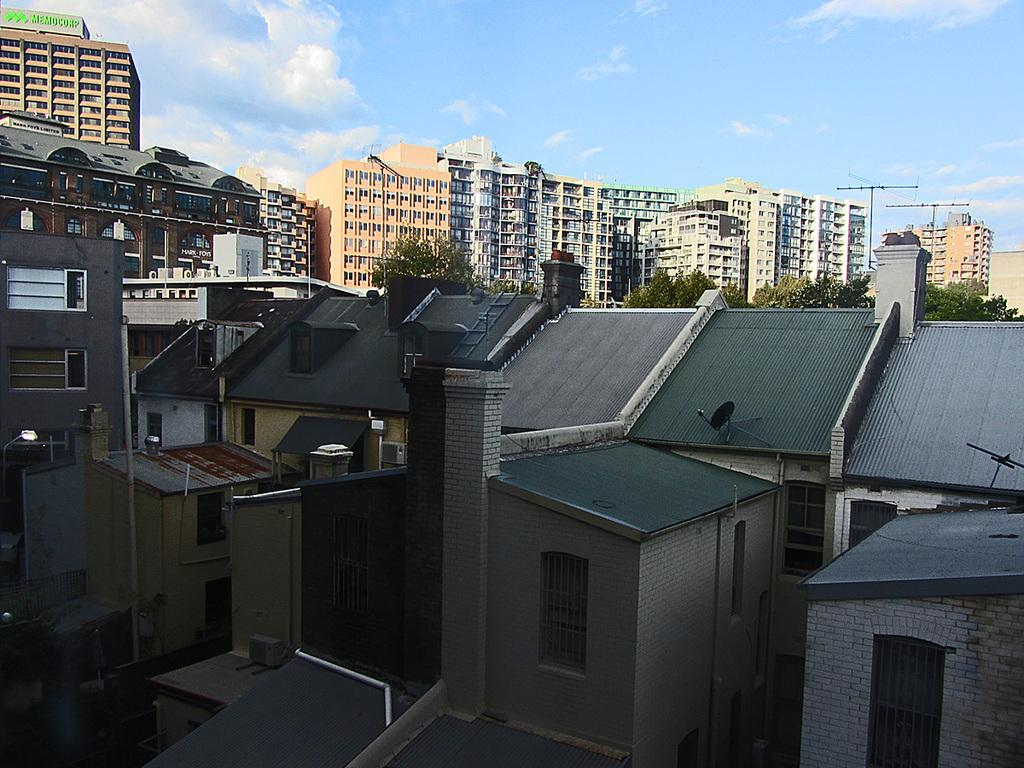What types of structures are present in the image? There are multiple buildings in the image. What other natural elements can be seen in the image? There are trees in the image. What can be seen in the distance in the image? The sky is visible in the background of the image. What year is depicted in the image? The image does not depict a specific year; it is a general scene of buildings, trees, and the sky. What form does the idea of the image take? The image is a visual representation, not an idea, so it does not have a form in that sense. 